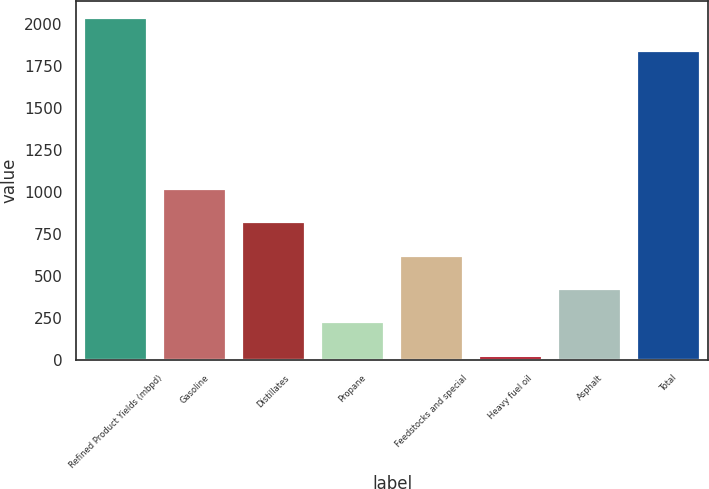<chart> <loc_0><loc_0><loc_500><loc_500><bar_chart><fcel>Refined Product Yields (mbpd)<fcel>Gasoline<fcel>Distillates<fcel>Propane<fcel>Feedstocks and special<fcel>Heavy fuel oil<fcel>Asphalt<fcel>Total<nl><fcel>2037.9<fcel>1019.5<fcel>820.6<fcel>223.9<fcel>621.7<fcel>25<fcel>422.8<fcel>1839<nl></chart> 